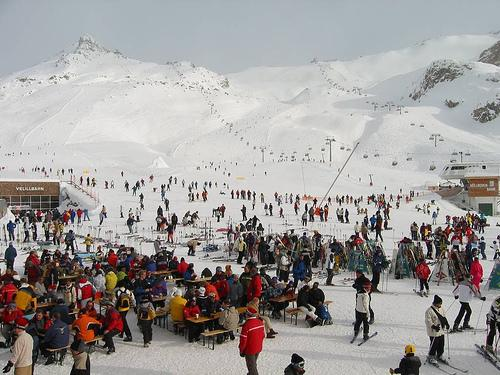What is on the floor? Please explain your reasoning. sand. It's snow on the ground 